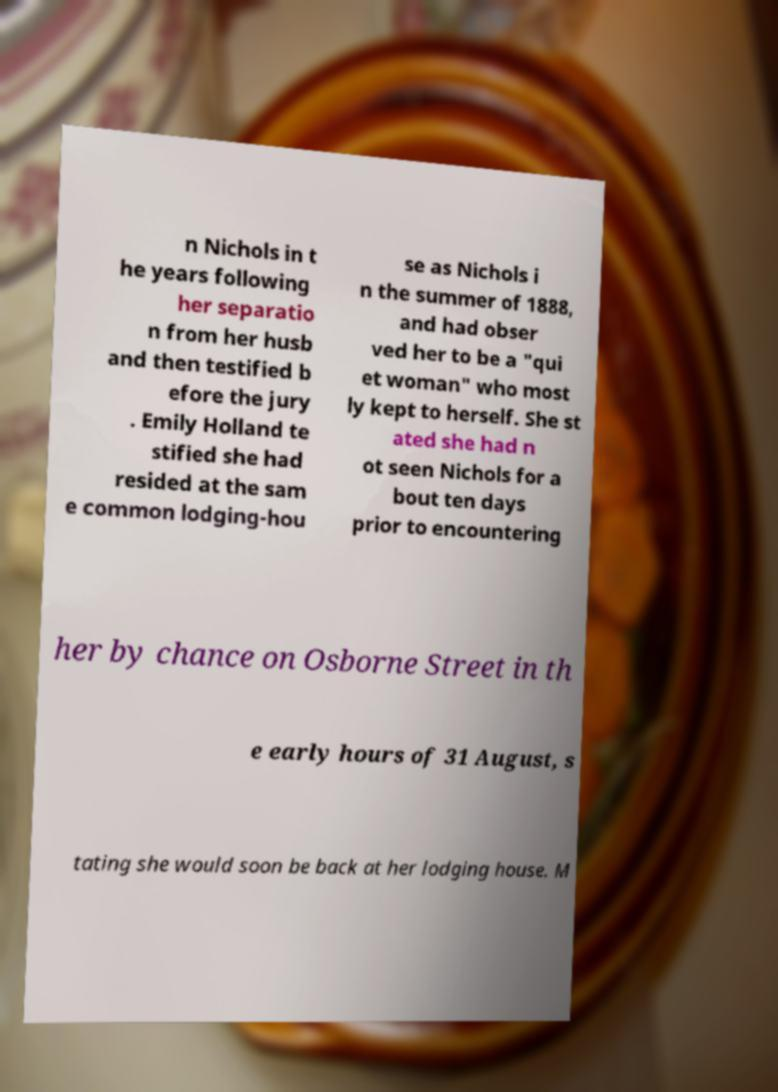Could you assist in decoding the text presented in this image and type it out clearly? n Nichols in t he years following her separatio n from her husb and then testified b efore the jury . Emily Holland te stified she had resided at the sam e common lodging-hou se as Nichols i n the summer of 1888, and had obser ved her to be a "qui et woman" who most ly kept to herself. She st ated she had n ot seen Nichols for a bout ten days prior to encountering her by chance on Osborne Street in th e early hours of 31 August, s tating she would soon be back at her lodging house. M 